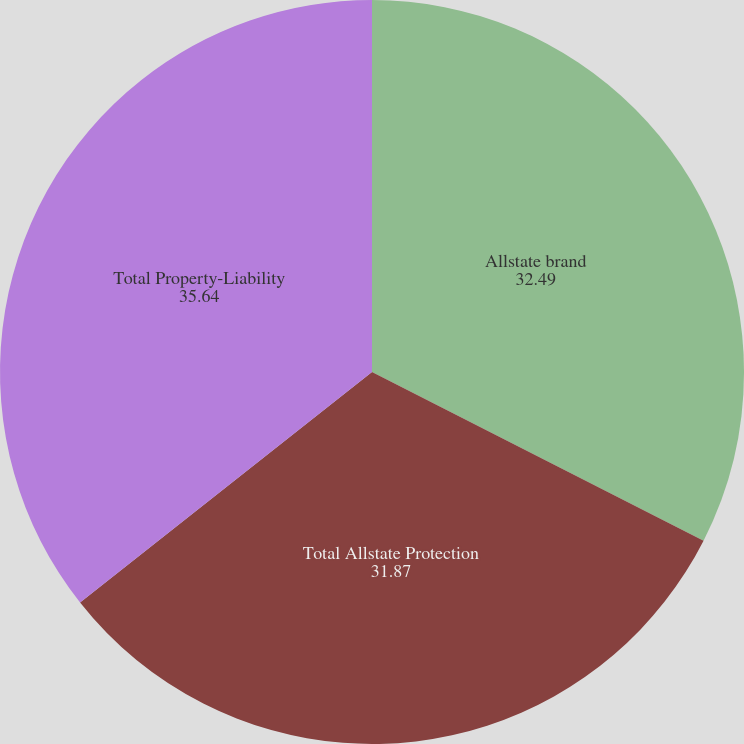<chart> <loc_0><loc_0><loc_500><loc_500><pie_chart><fcel>Allstate brand<fcel>Total Allstate Protection<fcel>Total Property-Liability<nl><fcel>32.49%<fcel>31.87%<fcel>35.64%<nl></chart> 